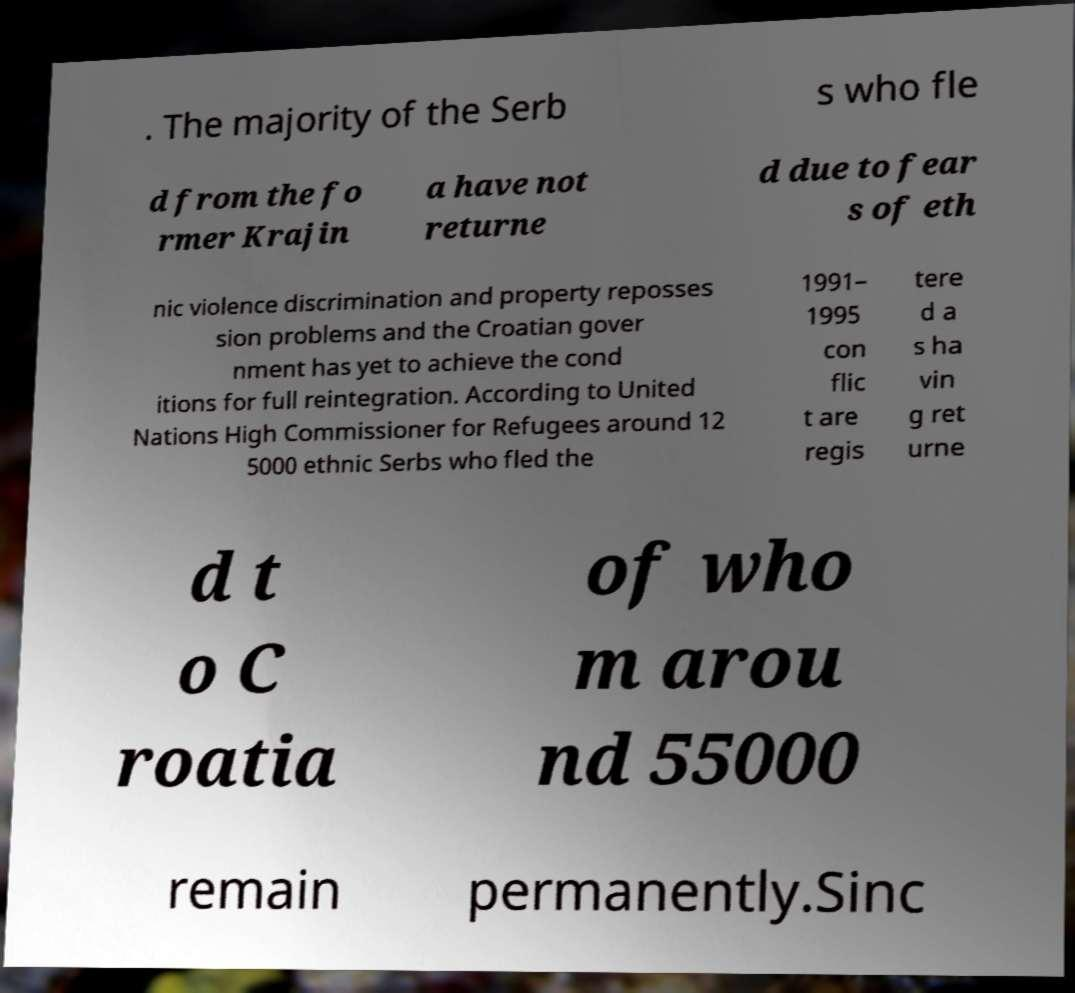Can you read and provide the text displayed in the image?This photo seems to have some interesting text. Can you extract and type it out for me? . The majority of the Serb s who fle d from the fo rmer Krajin a have not returne d due to fear s of eth nic violence discrimination and property reposses sion problems and the Croatian gover nment has yet to achieve the cond itions for full reintegration. According to United Nations High Commissioner for Refugees around 12 5000 ethnic Serbs who fled the 1991– 1995 con flic t are regis tere d a s ha vin g ret urne d t o C roatia of who m arou nd 55000 remain permanently.Sinc 